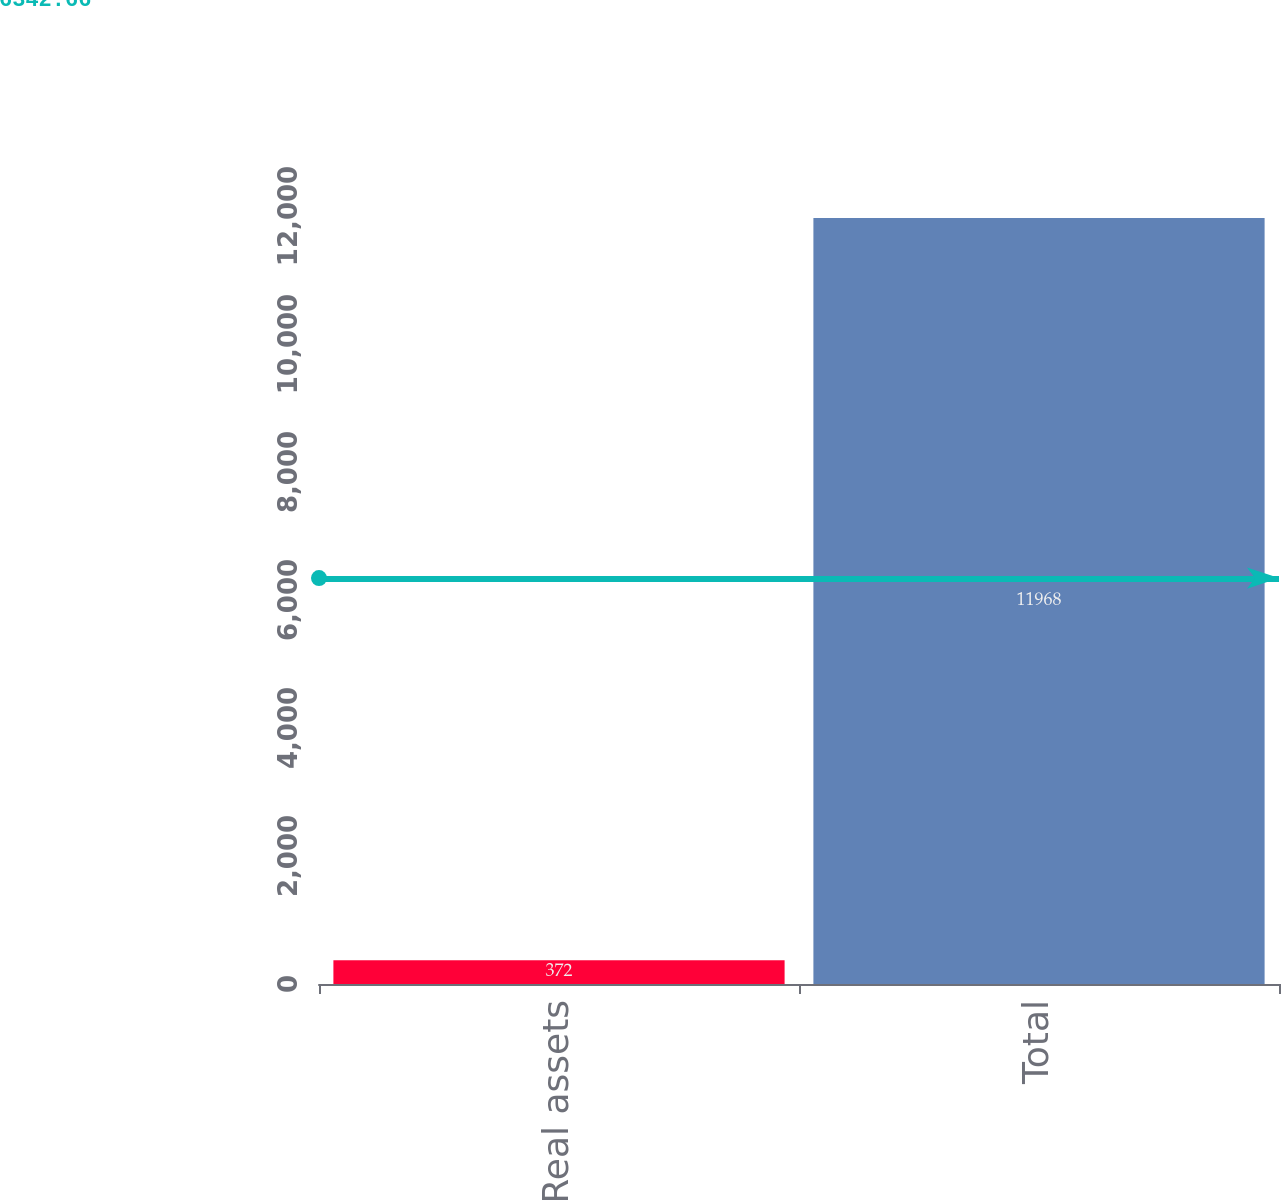<chart> <loc_0><loc_0><loc_500><loc_500><bar_chart><fcel>Real assets<fcel>Total<nl><fcel>372<fcel>11968<nl></chart> 